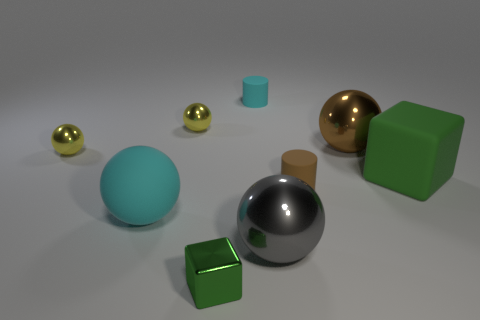Add 1 small green metallic objects. How many objects exist? 10 Subtract all big cyan rubber spheres. How many spheres are left? 4 Subtract all green cylinders. Subtract all gray blocks. How many cylinders are left? 2 Subtract all purple blocks. How many gray spheres are left? 1 Subtract all yellow spheres. How many spheres are left? 3 Subtract 0 cyan cubes. How many objects are left? 9 Subtract all spheres. How many objects are left? 4 Subtract 3 balls. How many balls are left? 2 Subtract all small shiny balls. Subtract all brown metallic objects. How many objects are left? 6 Add 5 rubber blocks. How many rubber blocks are left? 6 